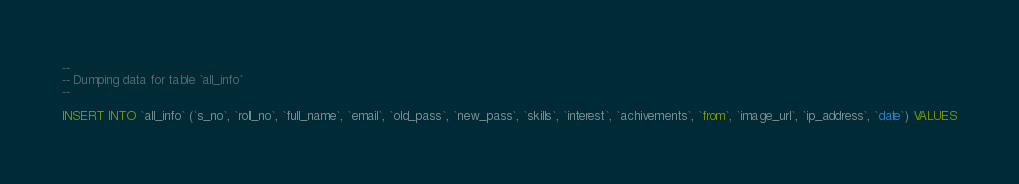Convert code to text. <code><loc_0><loc_0><loc_500><loc_500><_SQL_>
--
-- Dumping data for table `all_info`
--

INSERT INTO `all_info` (`s_no`, `roll_no`, `full_name`, `email`, `old_pass`, `new_pass`, `skills`, `interest`, `achivements`, `from`, `image_url`, `ip_address`, `date`) VALUES</code> 